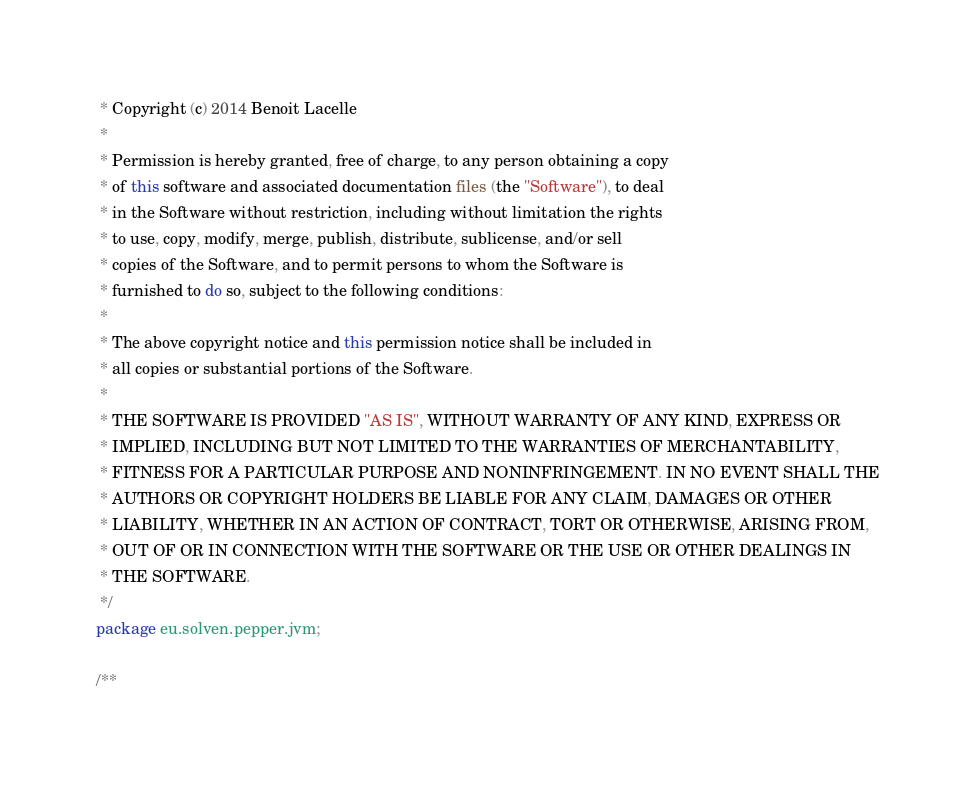Convert code to text. <code><loc_0><loc_0><loc_500><loc_500><_Java_> * Copyright (c) 2014 Benoit Lacelle
 *
 * Permission is hereby granted, free of charge, to any person obtaining a copy
 * of this software and associated documentation files (the "Software"), to deal
 * in the Software without restriction, including without limitation the rights
 * to use, copy, modify, merge, publish, distribute, sublicense, and/or sell
 * copies of the Software, and to permit persons to whom the Software is
 * furnished to do so, subject to the following conditions:
 *
 * The above copyright notice and this permission notice shall be included in
 * all copies or substantial portions of the Software.
 *
 * THE SOFTWARE IS PROVIDED "AS IS", WITHOUT WARRANTY OF ANY KIND, EXPRESS OR
 * IMPLIED, INCLUDING BUT NOT LIMITED TO THE WARRANTIES OF MERCHANTABILITY,
 * FITNESS FOR A PARTICULAR PURPOSE AND NONINFRINGEMENT. IN NO EVENT SHALL THE
 * AUTHORS OR COPYRIGHT HOLDERS BE LIABLE FOR ANY CLAIM, DAMAGES OR OTHER
 * LIABILITY, WHETHER IN AN ACTION OF CONTRACT, TORT OR OTHERWISE, ARISING FROM,
 * OUT OF OR IN CONNECTION WITH THE SOFTWARE OR THE USE OR OTHER DEALINGS IN
 * THE SOFTWARE.
 */
package eu.solven.pepper.jvm;

/**</code> 